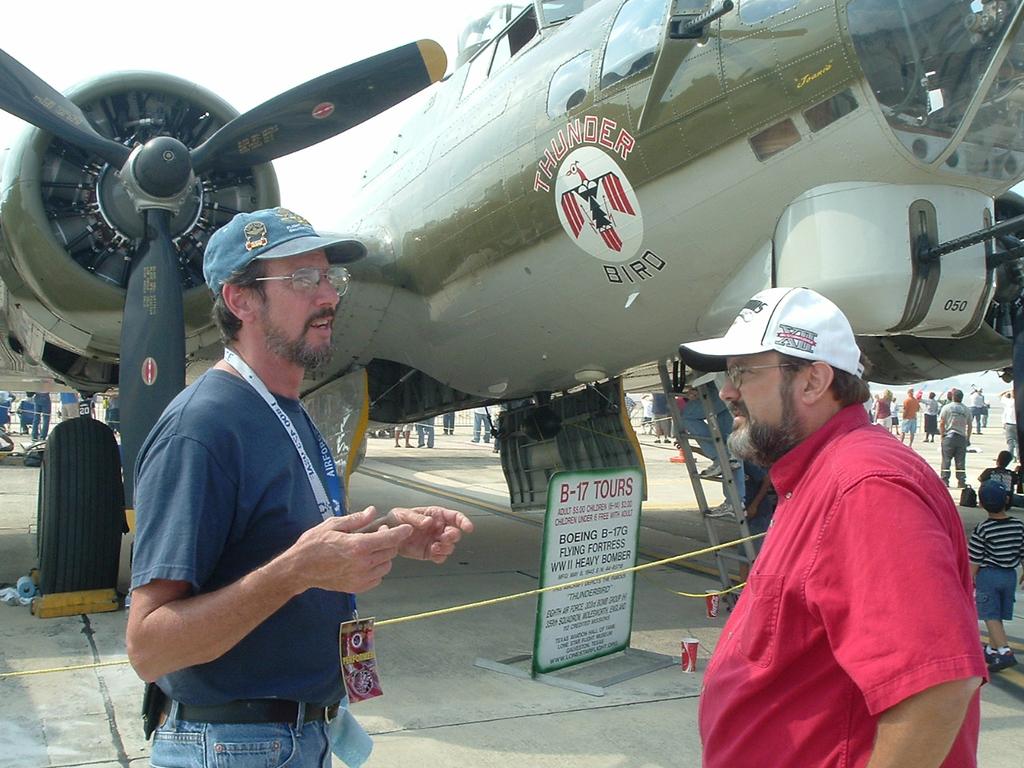What kind of airplane is this?
Provide a short and direct response. B-17. Are those for just one person?
Your answer should be very brief. No. 